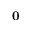<formula> <loc_0><loc_0><loc_500><loc_500>{ 0 }</formula> 